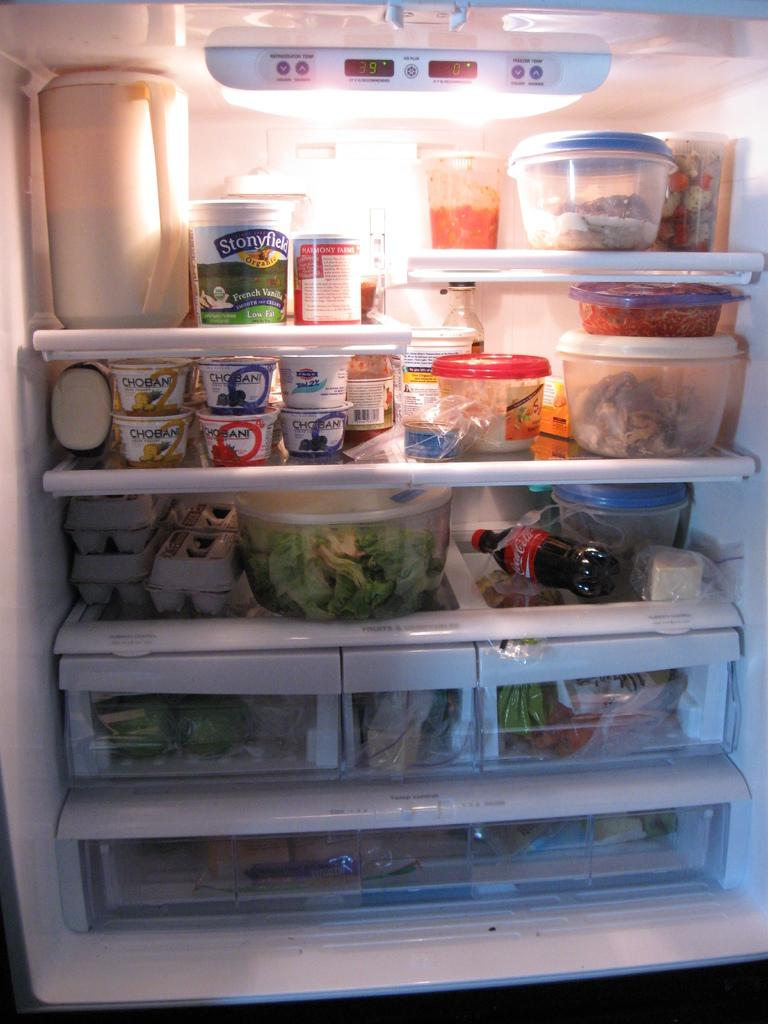<image>
Provide a brief description of the given image. A fully stocked refrigerator, including Stonyfield French Vanilla yogurt, pineapple, blueberry, and strawberry Chobani yogurt, eggs, and vegetables. 